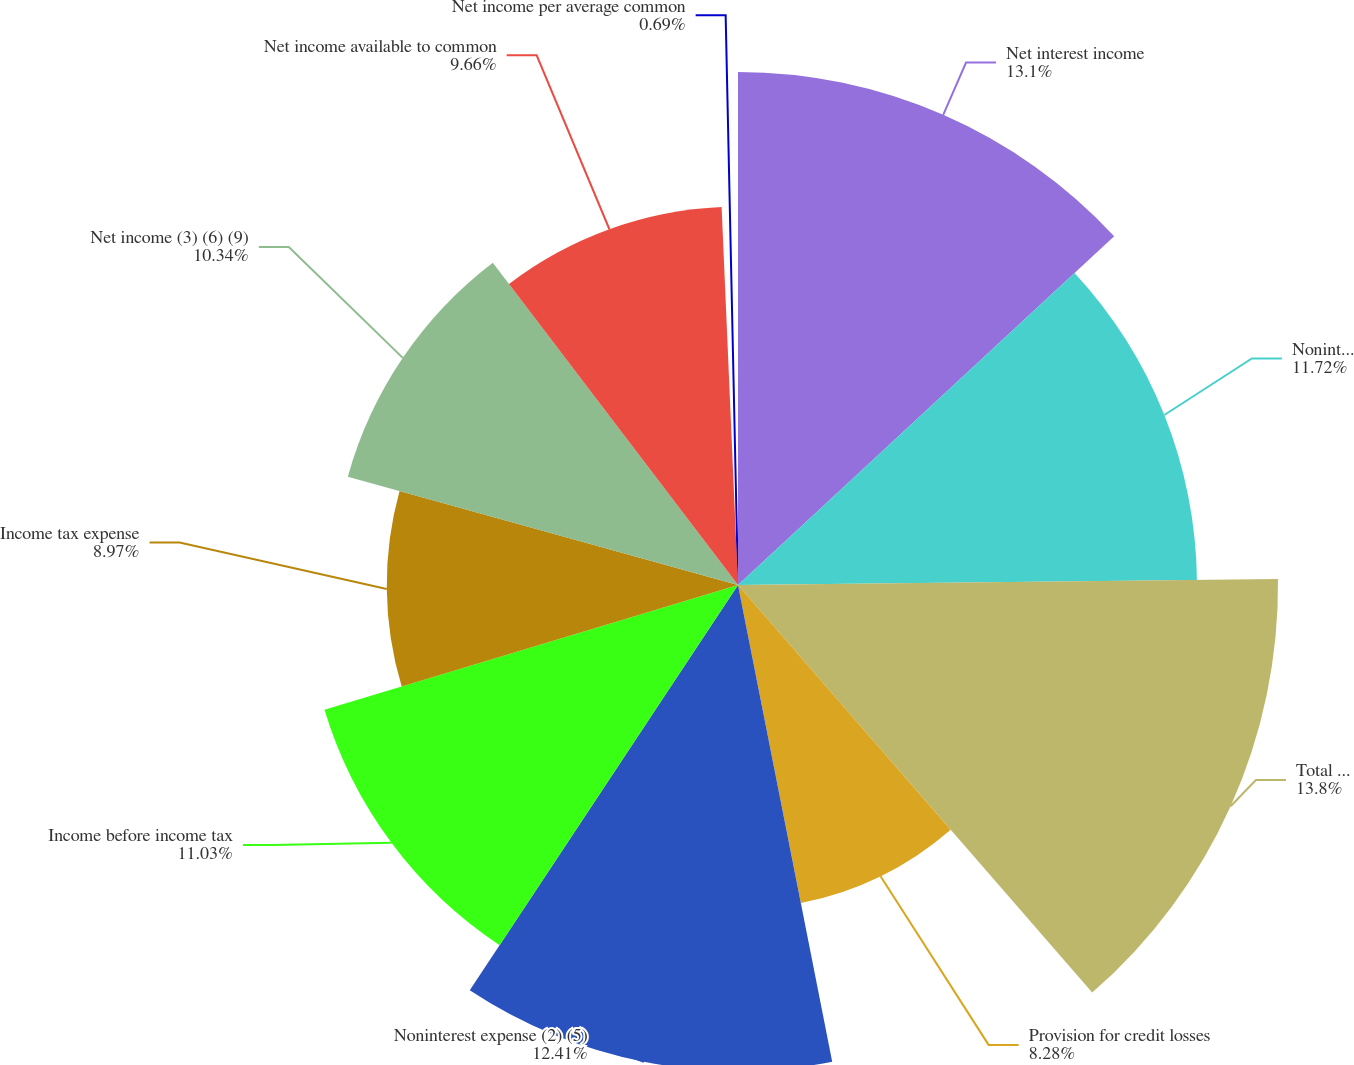Convert chart. <chart><loc_0><loc_0><loc_500><loc_500><pie_chart><fcel>Net interest income<fcel>Noninterest income (1)<fcel>Total revenue<fcel>Provision for credit losses<fcel>Noninterest expense (2) (5)<fcel>Income before income tax<fcel>Income tax expense<fcel>Net income (3) (6) (9)<fcel>Net income available to common<fcel>Net income per average common<nl><fcel>13.1%<fcel>11.72%<fcel>13.79%<fcel>8.28%<fcel>12.41%<fcel>11.03%<fcel>8.97%<fcel>10.34%<fcel>9.66%<fcel>0.69%<nl></chart> 